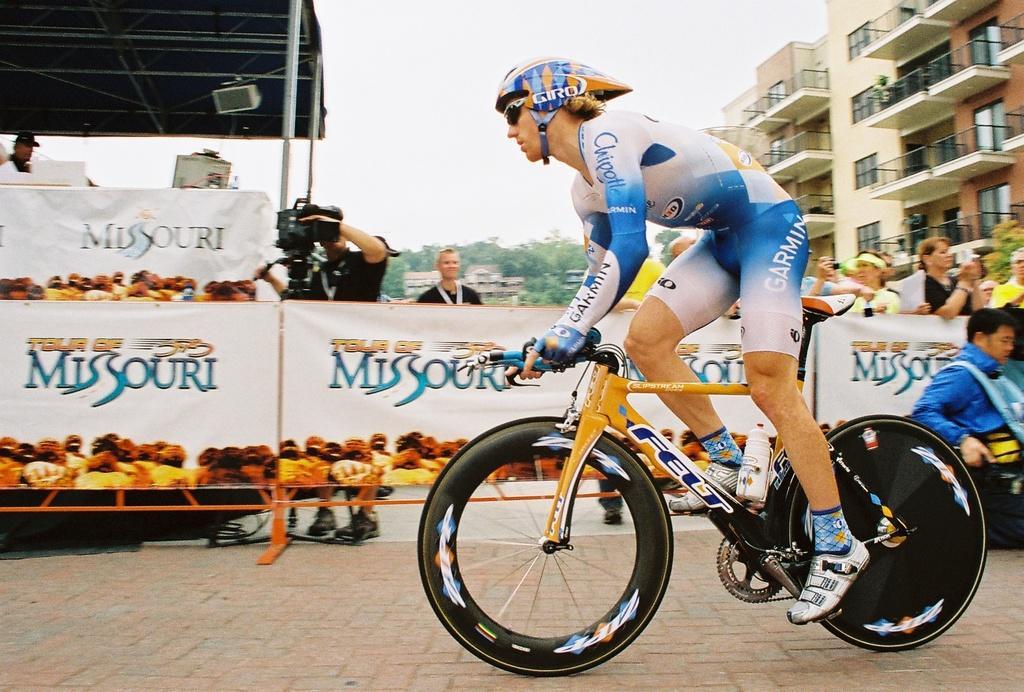Describe this image in one or two sentences. In this image I can see a man is cycling a cycle. I can also see he is wearing shades and a helmet. In the background I can see few more people where one of them is holding a camera. I can also see few buildings and number of trees. 